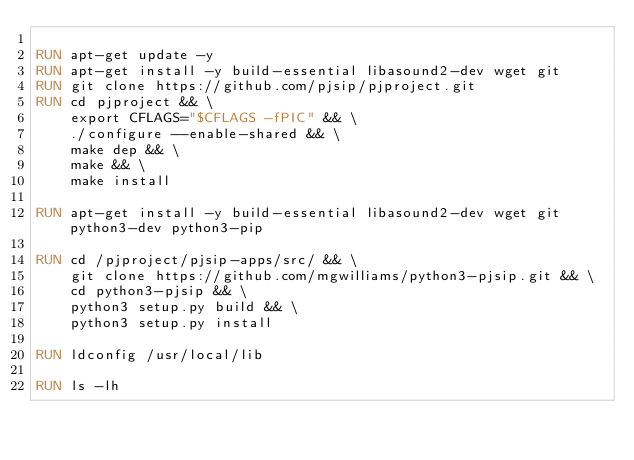<code> <loc_0><loc_0><loc_500><loc_500><_Dockerfile_>
RUN apt-get update -y
RUN apt-get install -y build-essential libasound2-dev wget git
RUN git clone https://github.com/pjsip/pjproject.git
RUN cd pjproject && \
    export CFLAGS="$CFLAGS -fPIC" && \
    ./configure --enable-shared && \
    make dep && \
    make && \
    make install

RUN apt-get install -y build-essential libasound2-dev wget git python3-dev python3-pip

RUN cd /pjproject/pjsip-apps/src/ && \
    git clone https://github.com/mgwilliams/python3-pjsip.git && \
    cd python3-pjsip && \
    python3 setup.py build && \
    python3 setup.py install

RUN ldconfig /usr/local/lib

RUN ls -lh</code> 